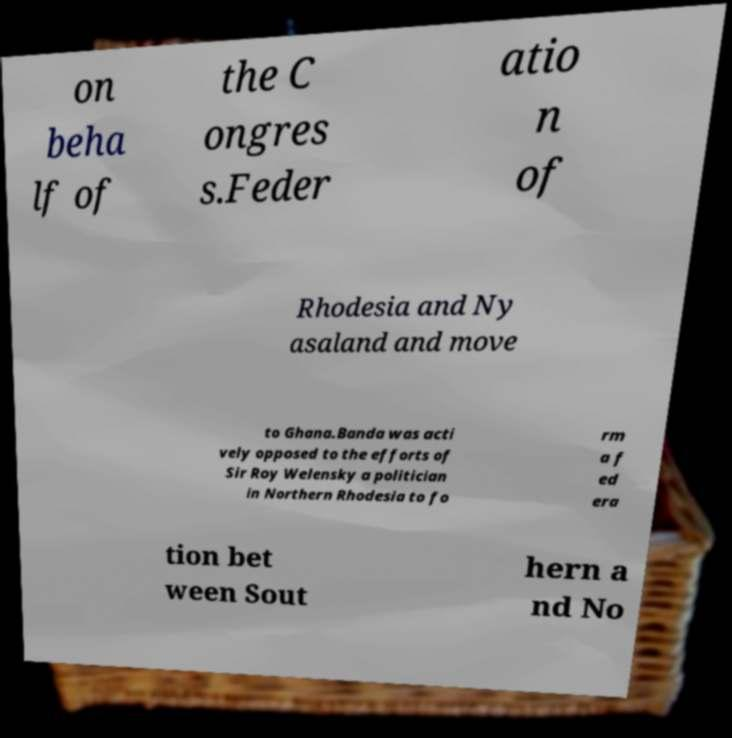Could you assist in decoding the text presented in this image and type it out clearly? on beha lf of the C ongres s.Feder atio n of Rhodesia and Ny asaland and move to Ghana.Banda was acti vely opposed to the efforts of Sir Roy Welensky a politician in Northern Rhodesia to fo rm a f ed era tion bet ween Sout hern a nd No 